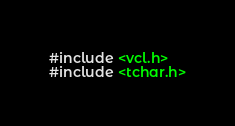<code> <loc_0><loc_0><loc_500><loc_500><_C_>#include <vcl.h>
#include <tchar.h>

</code> 